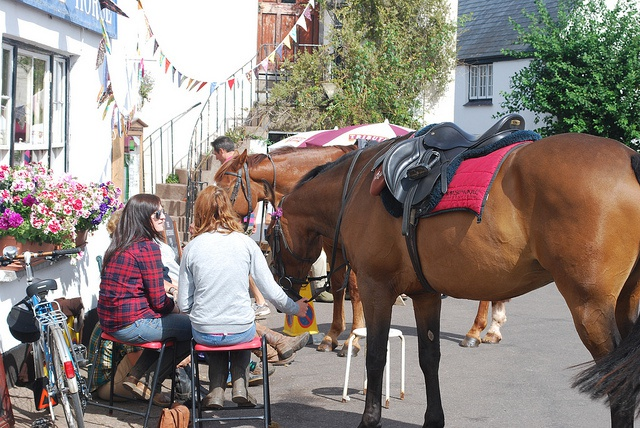Describe the objects in this image and their specific colors. I can see horse in darkgray, black, maroon, and gray tones, people in darkgray, white, black, and gray tones, people in darkgray, black, gray, brown, and maroon tones, horse in darkgray, brown, maroon, black, and gray tones, and bicycle in darkgray, gray, black, and lightgray tones in this image. 